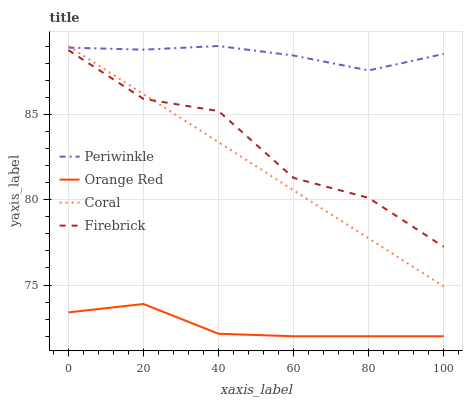Does Orange Red have the minimum area under the curve?
Answer yes or no. Yes. Does Periwinkle have the maximum area under the curve?
Answer yes or no. Yes. Does Coral have the minimum area under the curve?
Answer yes or no. No. Does Coral have the maximum area under the curve?
Answer yes or no. No. Is Coral the smoothest?
Answer yes or no. Yes. Is Firebrick the roughest?
Answer yes or no. Yes. Is Periwinkle the smoothest?
Answer yes or no. No. Is Periwinkle the roughest?
Answer yes or no. No. Does Orange Red have the lowest value?
Answer yes or no. Yes. Does Coral have the lowest value?
Answer yes or no. No. Does Periwinkle have the highest value?
Answer yes or no. Yes. Does Orange Red have the highest value?
Answer yes or no. No. Is Orange Red less than Coral?
Answer yes or no. Yes. Is Coral greater than Orange Red?
Answer yes or no. Yes. Does Coral intersect Periwinkle?
Answer yes or no. Yes. Is Coral less than Periwinkle?
Answer yes or no. No. Is Coral greater than Periwinkle?
Answer yes or no. No. Does Orange Red intersect Coral?
Answer yes or no. No. 